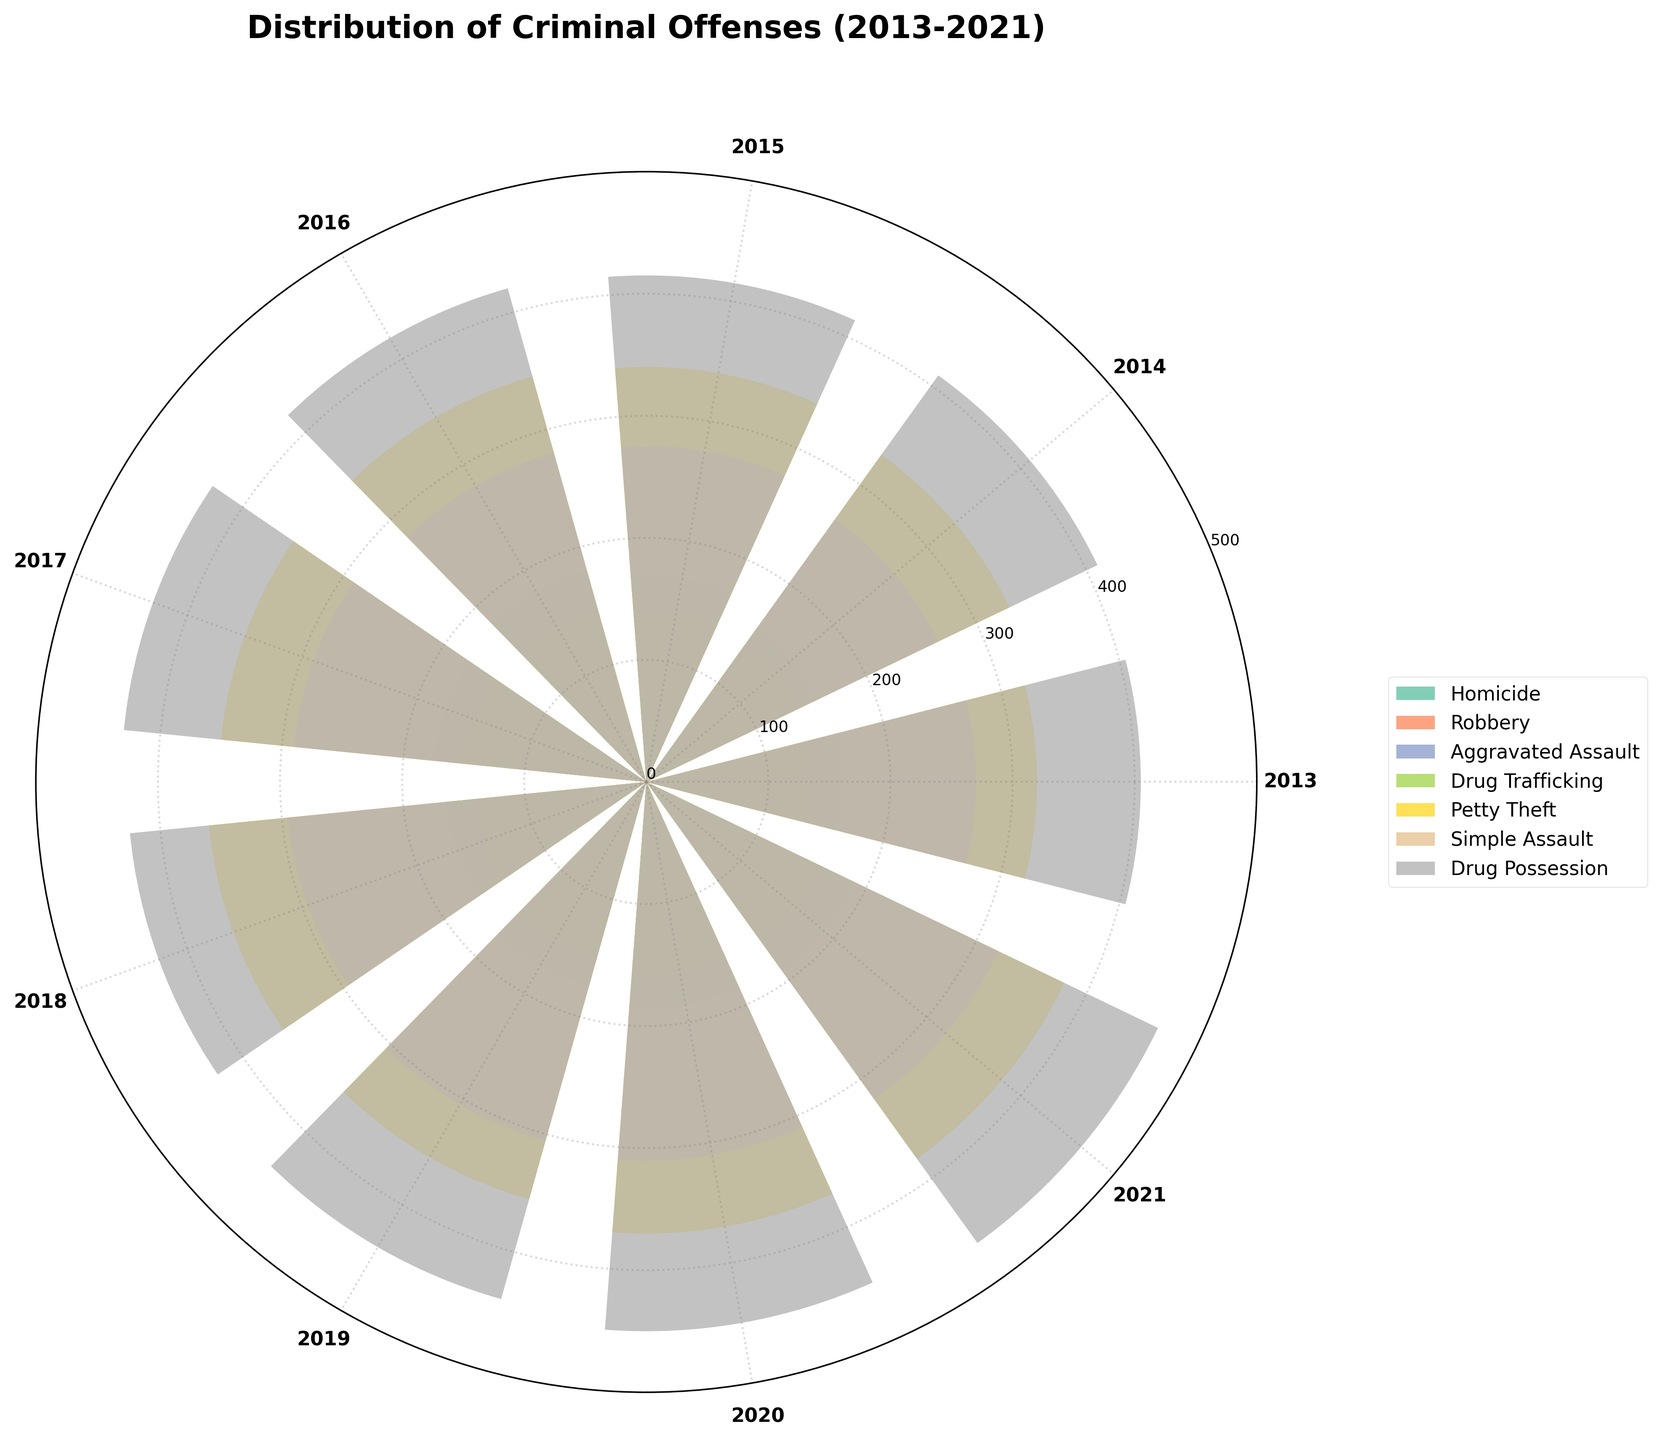What's the title of the figure? The title of the figure is typically placed prominently at the top and is written in a larger, bold font. It helps to identify the subject of the figure quickly.
Answer: Distribution of Criminal Offenses (2013-2021) What is the color of the bar representing Drug Trafficking offenses? Different offenses are represented by different colors in the rose chart, which are usually distinguished in the legend. Identifying the color involves matching the label "Drug Trafficking" in the legend to its color bar.
Answer: Blue (from matplotlib's Set2 color palette) Which year had the highest count of Homicide cases and what was the count? Look at the bars representing Homicide in the rose chart and identify the bar that extends furthest from the center. The year labeled on the corresponding radial axis provides the highest count year. The legend and theta-tick values are used for this purpose.
Answer: 2021, 72 In 2020, how much higher was the count of Misdemeanor Drug Possession offenses compared to 2017? First, find the bars representing Misdemeanor Drug Possession for both 2020 and 2017. Measure the length from the center for both years. The difference between these two values will give the answer. 2020 Drug Possession count is 450 and 2017 Drug Possession count is 430. So, 450 - 430 = 20.
Answer: 20 Which offense showed the most consistent trend over the years? To determine the consistency, observe the fluctuation of the bars for each offense. The offense with bars at relatively the same level over all the years represents a consistent trend.
Answer: Misdemeanor Petty Theft For the year 2019, rank the offenses from least to most in counts. Identify the lengths of bars corresponding to each offense for the year 2019. Rank these lengths from shortest to longest. Offenses in 2019 are: Homicide (61), Robbery (148), Aggravated Assault (113), Drug Trafficking (174), Petty Theft (355), Simple Assault (305), Drug Possession (440).
Answer: Homicide < Aggravated Assault < Robbery < Drug Trafficking < Simple Assault < Petty Theft < Drug Possession Which misdemeanor offense had the highest count on average over the years? Calculate the average count for each misdemeanor offense (Petty Theft, Simple Assault, Drug Possession) over the years by summing the yearly counts and dividing by the number of years. Then compare these averages. Petty Theft: (320+330+340+345+350+360+355+370+380)/9 = 351.11. Simple Assault: (270+265+275+280+290+295+305+310+320)/9 = 290. Drug Possession: (405+410+415+420+430+425+440+450+465)/9 = 435.
Answer: Drug Possession How did the count of felony Robbery offenses change from 2013 to 2021? Identify the bar representing felony Robbery for both 2013 and 2021. Compare the heights to determine the difference in counts. Robbery count in 2013 is 130 and in 2021 is 160. So, 160-130 = 30.
Answer: Increased by 30 What is the total number of felony offenses in 2020? Sum the counts of all felony offenses (Homicide, Robbery, Aggravated Assault, Drug Trafficking) for the year 2020. Homicide: 70, Robbery: 155, Aggravated Assault: 125, Drug Trafficking: 185. Total = 70 + 155 + 125 + 185 = 535.
Answer: 535 